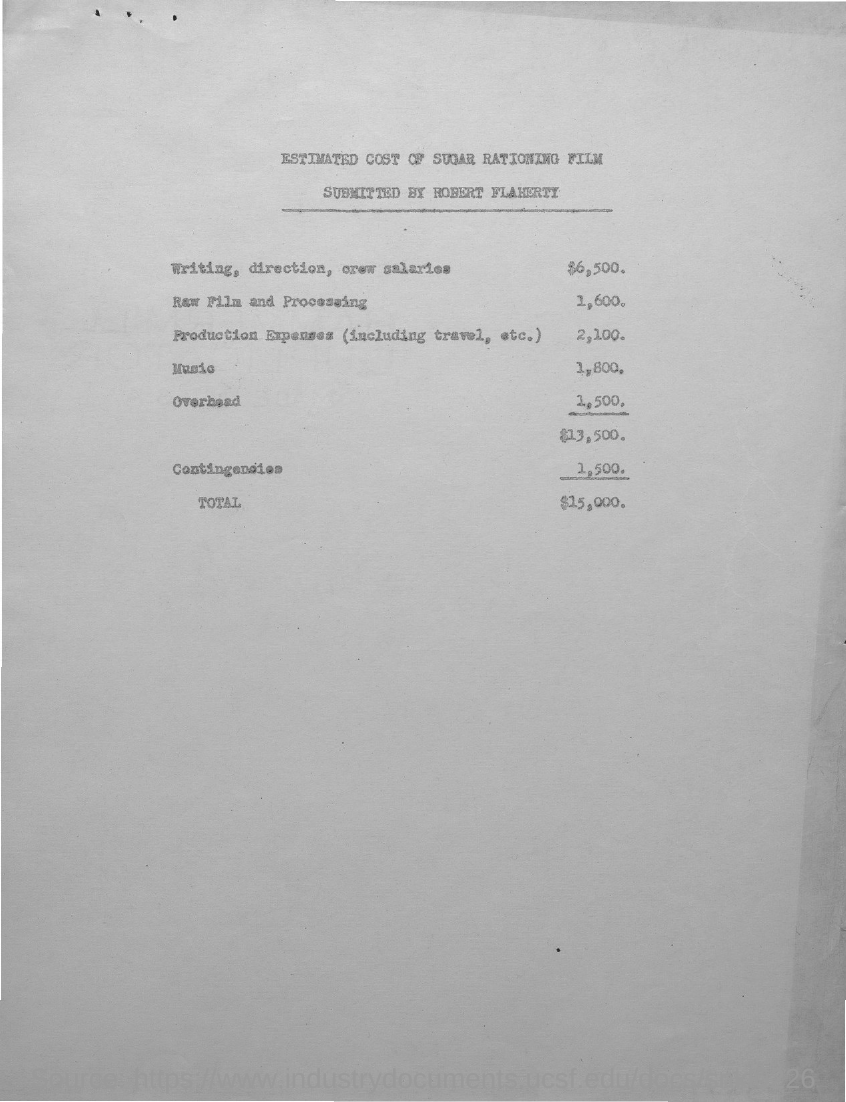Draw attention to some important aspects in this diagram. The total amount of the job is $15,000. 